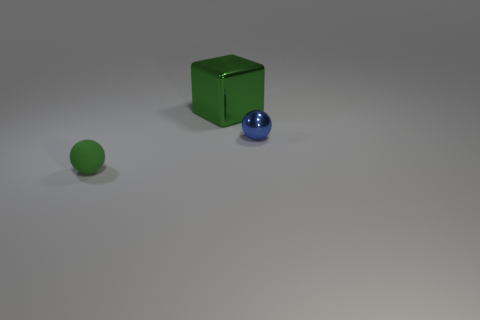Add 3 small blue spheres. How many objects exist? 6 Subtract all blue spheres. How many spheres are left? 1 Add 2 yellow shiny cubes. How many yellow shiny cubes exist? 2 Subtract 0 brown cylinders. How many objects are left? 3 Subtract all spheres. How many objects are left? 1 Subtract all small blue objects. Subtract all green rubber spheres. How many objects are left? 1 Add 3 big cubes. How many big cubes are left? 4 